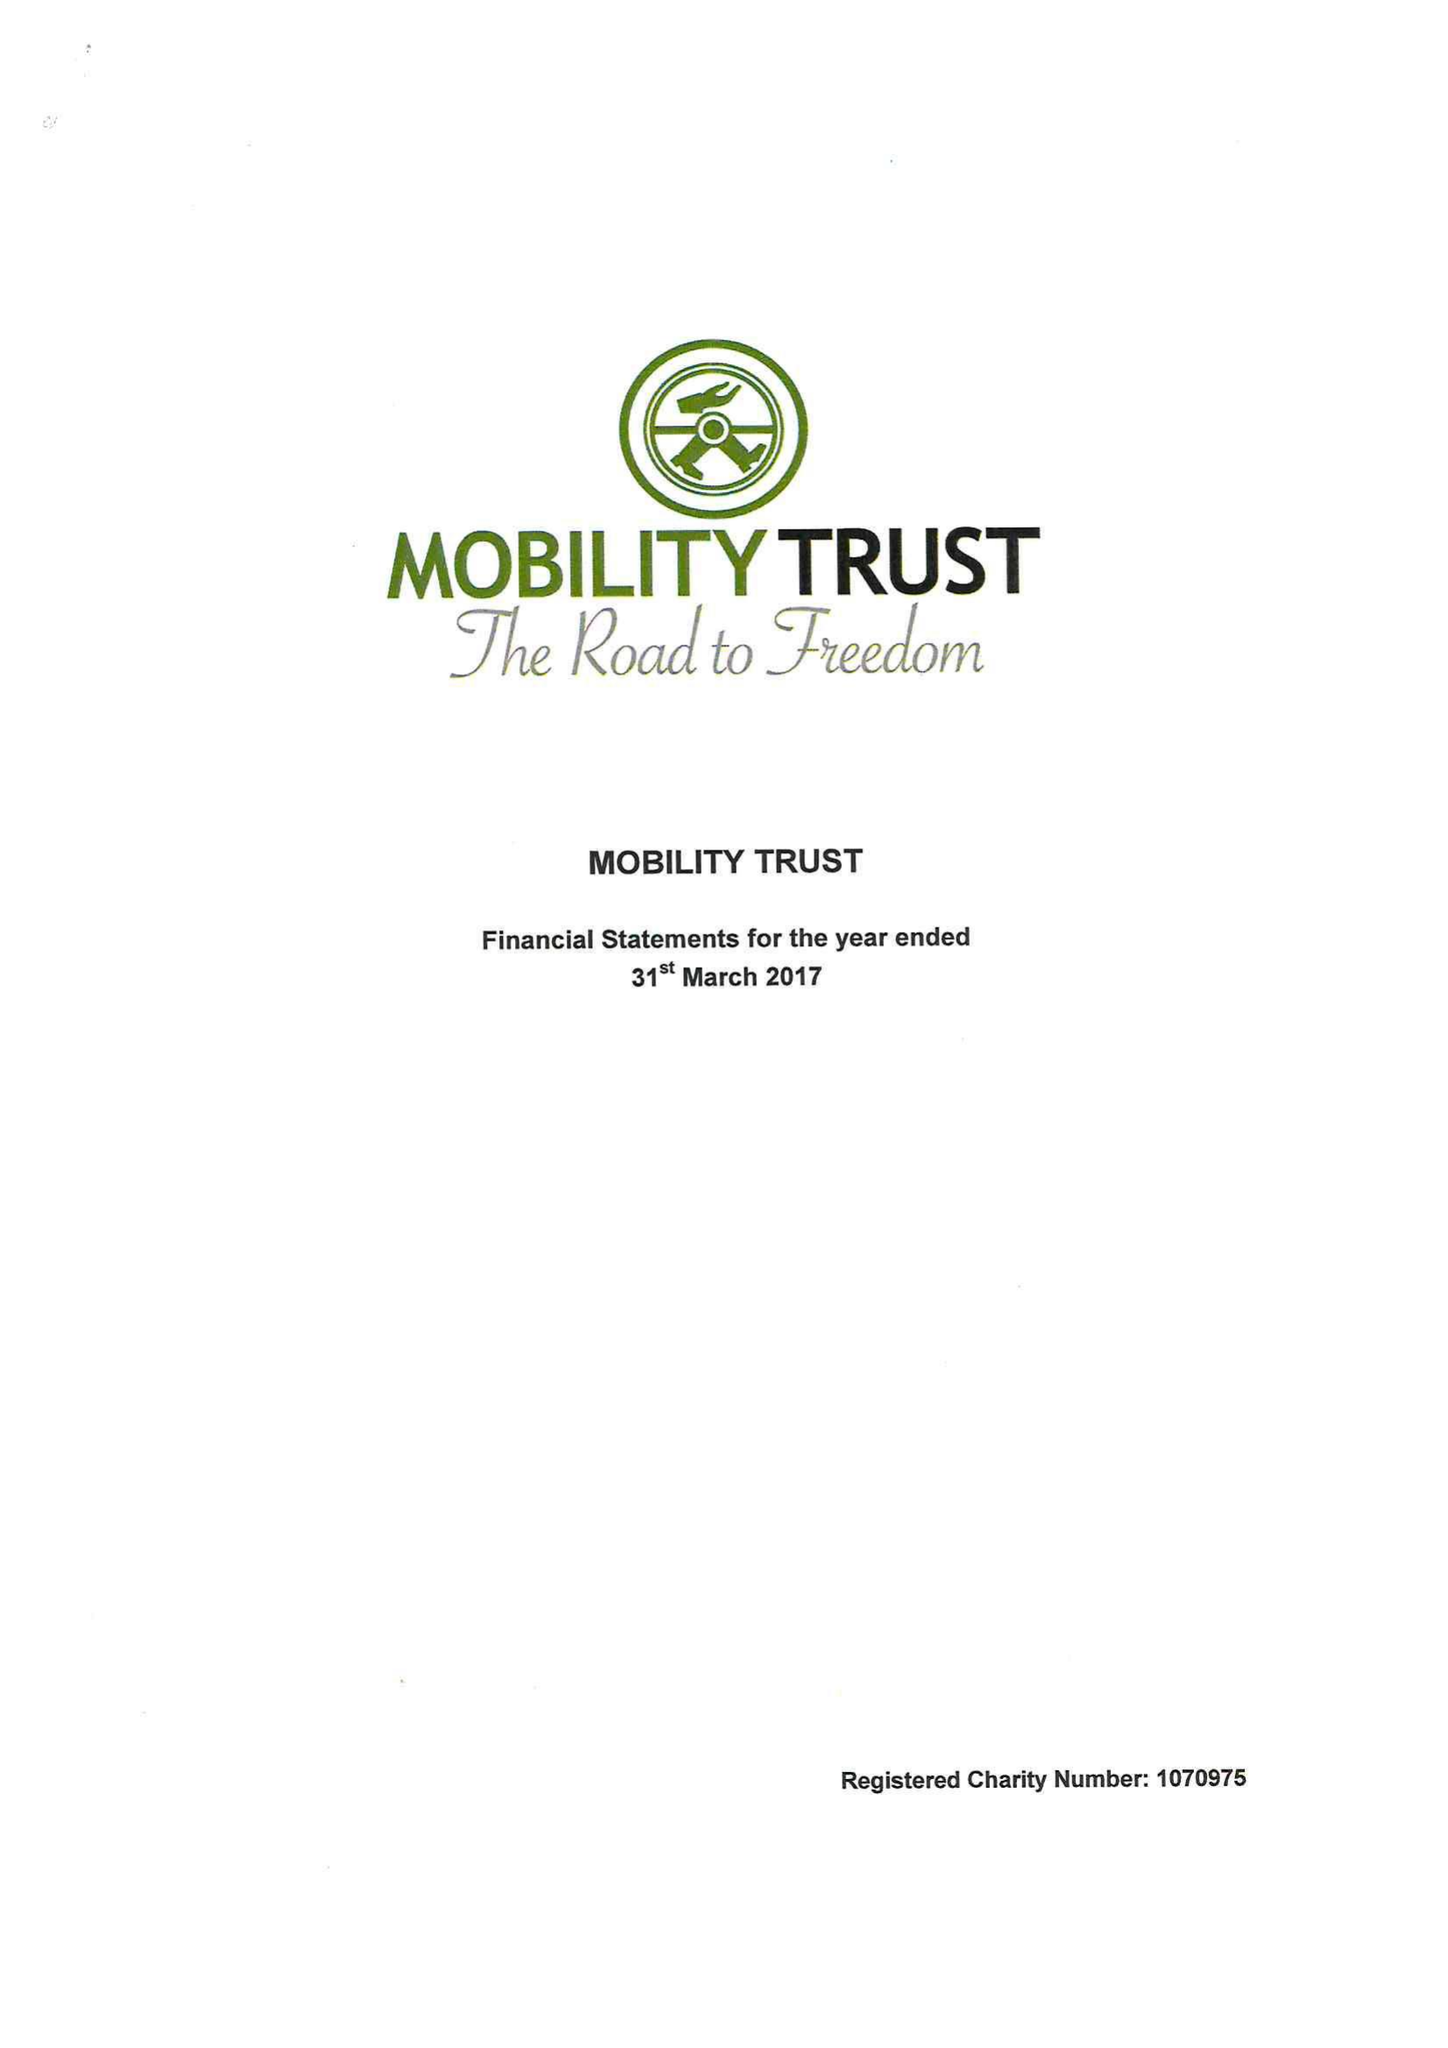What is the value for the spending_annually_in_british_pounds?
Answer the question using a single word or phrase. 394763.00 